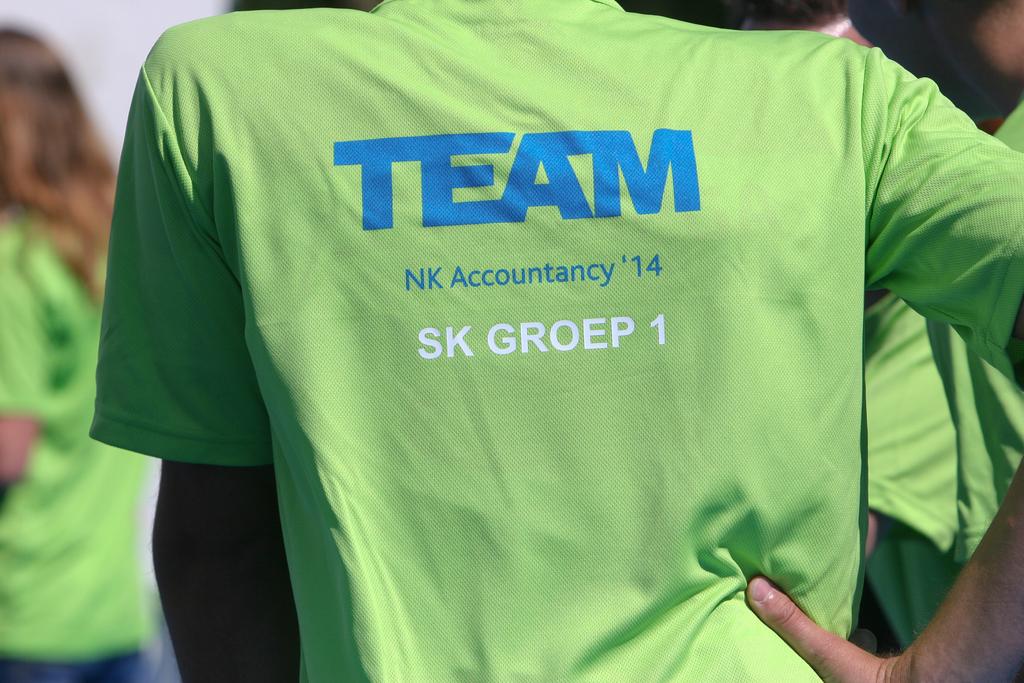What do the big blue letters say?
Provide a succinct answer. Team. 